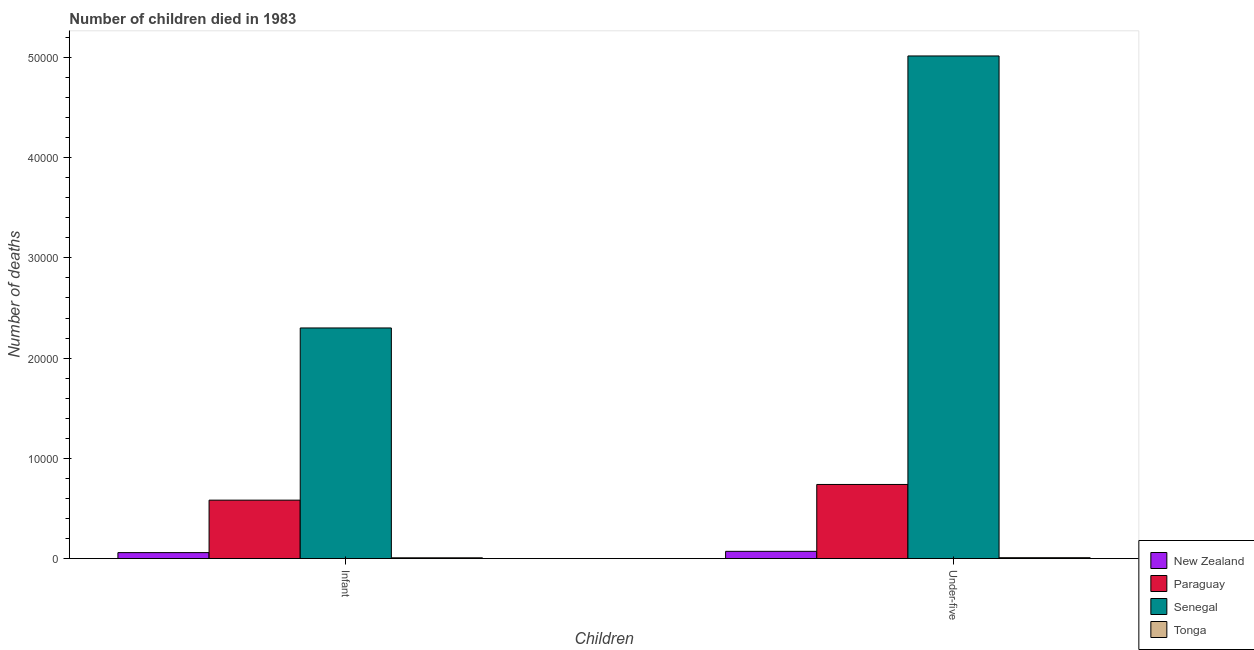How many different coloured bars are there?
Your answer should be compact. 4. How many groups of bars are there?
Make the answer very short. 2. Are the number of bars per tick equal to the number of legend labels?
Your answer should be compact. Yes. Are the number of bars on each tick of the X-axis equal?
Your answer should be compact. Yes. How many bars are there on the 1st tick from the left?
Give a very brief answer. 4. What is the label of the 2nd group of bars from the left?
Offer a terse response. Under-five. What is the number of infant deaths in New Zealand?
Give a very brief answer. 594. Across all countries, what is the maximum number of infant deaths?
Provide a succinct answer. 2.30e+04. Across all countries, what is the minimum number of under-five deaths?
Offer a very short reply. 87. In which country was the number of under-five deaths maximum?
Provide a short and direct response. Senegal. In which country was the number of under-five deaths minimum?
Provide a short and direct response. Tonga. What is the total number of under-five deaths in the graph?
Provide a short and direct response. 5.83e+04. What is the difference between the number of infant deaths in Paraguay and that in Senegal?
Offer a very short reply. -1.72e+04. What is the difference between the number of under-five deaths in Senegal and the number of infant deaths in Paraguay?
Make the answer very short. 4.43e+04. What is the average number of infant deaths per country?
Make the answer very short. 7376.75. What is the difference between the number of under-five deaths and number of infant deaths in New Zealand?
Make the answer very short. 128. What is the ratio of the number of infant deaths in Tonga to that in Paraguay?
Give a very brief answer. 0.01. In how many countries, is the number of under-five deaths greater than the average number of under-five deaths taken over all countries?
Make the answer very short. 1. What does the 2nd bar from the left in Infant represents?
Offer a very short reply. Paraguay. What does the 3rd bar from the right in Under-five represents?
Your answer should be compact. Paraguay. Are all the bars in the graph horizontal?
Give a very brief answer. No. How many countries are there in the graph?
Offer a terse response. 4. Does the graph contain any zero values?
Your answer should be compact. No. Does the graph contain grids?
Ensure brevity in your answer.  No. Where does the legend appear in the graph?
Offer a very short reply. Bottom right. How many legend labels are there?
Provide a short and direct response. 4. What is the title of the graph?
Ensure brevity in your answer.  Number of children died in 1983. Does "Switzerland" appear as one of the legend labels in the graph?
Your answer should be very brief. No. What is the label or title of the X-axis?
Ensure brevity in your answer.  Children. What is the label or title of the Y-axis?
Your answer should be very brief. Number of deaths. What is the Number of deaths in New Zealand in Infant?
Give a very brief answer. 594. What is the Number of deaths of Paraguay in Infant?
Offer a terse response. 5829. What is the Number of deaths of Senegal in Infant?
Offer a very short reply. 2.30e+04. What is the Number of deaths of New Zealand in Under-five?
Make the answer very short. 722. What is the Number of deaths of Paraguay in Under-five?
Keep it short and to the point. 7394. What is the Number of deaths in Senegal in Under-five?
Give a very brief answer. 5.01e+04. What is the Number of deaths in Tonga in Under-five?
Ensure brevity in your answer.  87. Across all Children, what is the maximum Number of deaths of New Zealand?
Offer a terse response. 722. Across all Children, what is the maximum Number of deaths of Paraguay?
Make the answer very short. 7394. Across all Children, what is the maximum Number of deaths in Senegal?
Offer a very short reply. 5.01e+04. Across all Children, what is the minimum Number of deaths in New Zealand?
Provide a succinct answer. 594. Across all Children, what is the minimum Number of deaths of Paraguay?
Your answer should be compact. 5829. Across all Children, what is the minimum Number of deaths in Senegal?
Your answer should be compact. 2.30e+04. What is the total Number of deaths of New Zealand in the graph?
Ensure brevity in your answer.  1316. What is the total Number of deaths of Paraguay in the graph?
Offer a terse response. 1.32e+04. What is the total Number of deaths of Senegal in the graph?
Make the answer very short. 7.32e+04. What is the total Number of deaths in Tonga in the graph?
Your answer should be very brief. 163. What is the difference between the Number of deaths of New Zealand in Infant and that in Under-five?
Keep it short and to the point. -128. What is the difference between the Number of deaths in Paraguay in Infant and that in Under-five?
Ensure brevity in your answer.  -1565. What is the difference between the Number of deaths of Senegal in Infant and that in Under-five?
Make the answer very short. -2.71e+04. What is the difference between the Number of deaths in Tonga in Infant and that in Under-five?
Your answer should be very brief. -11. What is the difference between the Number of deaths of New Zealand in Infant and the Number of deaths of Paraguay in Under-five?
Give a very brief answer. -6800. What is the difference between the Number of deaths of New Zealand in Infant and the Number of deaths of Senegal in Under-five?
Keep it short and to the point. -4.96e+04. What is the difference between the Number of deaths of New Zealand in Infant and the Number of deaths of Tonga in Under-five?
Your response must be concise. 507. What is the difference between the Number of deaths of Paraguay in Infant and the Number of deaths of Senegal in Under-five?
Keep it short and to the point. -4.43e+04. What is the difference between the Number of deaths of Paraguay in Infant and the Number of deaths of Tonga in Under-five?
Ensure brevity in your answer.  5742. What is the difference between the Number of deaths of Senegal in Infant and the Number of deaths of Tonga in Under-five?
Your response must be concise. 2.29e+04. What is the average Number of deaths in New Zealand per Children?
Provide a short and direct response. 658. What is the average Number of deaths in Paraguay per Children?
Offer a terse response. 6611.5. What is the average Number of deaths of Senegal per Children?
Keep it short and to the point. 3.66e+04. What is the average Number of deaths of Tonga per Children?
Provide a succinct answer. 81.5. What is the difference between the Number of deaths in New Zealand and Number of deaths in Paraguay in Infant?
Ensure brevity in your answer.  -5235. What is the difference between the Number of deaths in New Zealand and Number of deaths in Senegal in Infant?
Keep it short and to the point. -2.24e+04. What is the difference between the Number of deaths in New Zealand and Number of deaths in Tonga in Infant?
Provide a succinct answer. 518. What is the difference between the Number of deaths of Paraguay and Number of deaths of Senegal in Infant?
Offer a terse response. -1.72e+04. What is the difference between the Number of deaths in Paraguay and Number of deaths in Tonga in Infant?
Ensure brevity in your answer.  5753. What is the difference between the Number of deaths in Senegal and Number of deaths in Tonga in Infant?
Make the answer very short. 2.29e+04. What is the difference between the Number of deaths of New Zealand and Number of deaths of Paraguay in Under-five?
Give a very brief answer. -6672. What is the difference between the Number of deaths of New Zealand and Number of deaths of Senegal in Under-five?
Provide a short and direct response. -4.94e+04. What is the difference between the Number of deaths in New Zealand and Number of deaths in Tonga in Under-five?
Make the answer very short. 635. What is the difference between the Number of deaths of Paraguay and Number of deaths of Senegal in Under-five?
Your answer should be compact. -4.28e+04. What is the difference between the Number of deaths of Paraguay and Number of deaths of Tonga in Under-five?
Ensure brevity in your answer.  7307. What is the difference between the Number of deaths of Senegal and Number of deaths of Tonga in Under-five?
Ensure brevity in your answer.  5.01e+04. What is the ratio of the Number of deaths in New Zealand in Infant to that in Under-five?
Offer a very short reply. 0.82. What is the ratio of the Number of deaths in Paraguay in Infant to that in Under-five?
Offer a very short reply. 0.79. What is the ratio of the Number of deaths of Senegal in Infant to that in Under-five?
Make the answer very short. 0.46. What is the ratio of the Number of deaths of Tonga in Infant to that in Under-five?
Provide a succinct answer. 0.87. What is the difference between the highest and the second highest Number of deaths in New Zealand?
Your answer should be compact. 128. What is the difference between the highest and the second highest Number of deaths in Paraguay?
Provide a short and direct response. 1565. What is the difference between the highest and the second highest Number of deaths of Senegal?
Your response must be concise. 2.71e+04. What is the difference between the highest and the lowest Number of deaths in New Zealand?
Offer a very short reply. 128. What is the difference between the highest and the lowest Number of deaths of Paraguay?
Provide a short and direct response. 1565. What is the difference between the highest and the lowest Number of deaths in Senegal?
Your response must be concise. 2.71e+04. 